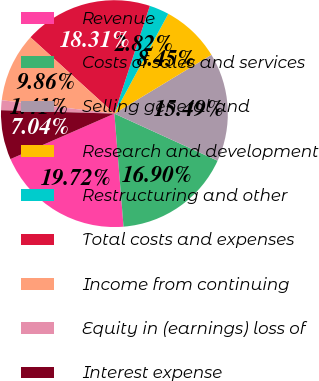Convert chart. <chart><loc_0><loc_0><loc_500><loc_500><pie_chart><fcel>Revenue<fcel>Costs of sales and services<fcel>Selling general and<fcel>Research and development<fcel>Restructuring and other<fcel>Total costs and expenses<fcel>Income from continuing<fcel>Equity in (earnings) loss of<fcel>Interest expense<nl><fcel>19.72%<fcel>16.9%<fcel>15.49%<fcel>8.45%<fcel>2.82%<fcel>18.31%<fcel>9.86%<fcel>1.41%<fcel>7.04%<nl></chart> 